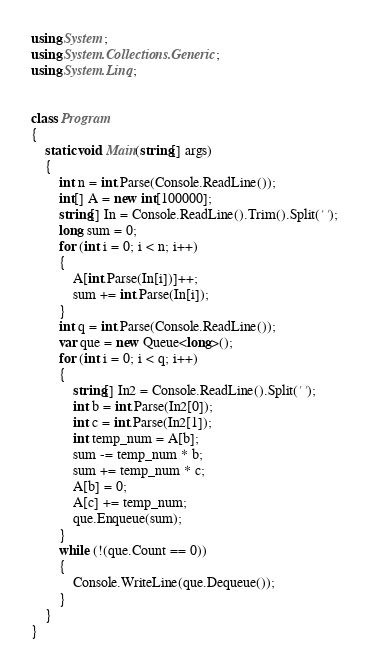<code> <loc_0><loc_0><loc_500><loc_500><_C#_>using System;
using System.Collections.Generic;
using System.Linq;


class Program
{
    static void Main(string[] args)
    {
        int n = int.Parse(Console.ReadLine());
        int[] A = new int[100000];
        string[] In = Console.ReadLine().Trim().Split(' ');
        long sum = 0;
        for (int i = 0; i < n; i++)
        {
            A[int.Parse(In[i])]++;
            sum += int.Parse(In[i]);
        }
        int q = int.Parse(Console.ReadLine());
        var que = new Queue<long>();
        for (int i = 0; i < q; i++)
        {
            string[] In2 = Console.ReadLine().Split(' ');
            int b = int.Parse(In2[0]);
            int c = int.Parse(In2[1]);
            int temp_num = A[b];
            sum -= temp_num * b;
            sum += temp_num * c;
            A[b] = 0;
            A[c] += temp_num;
            que.Enqueue(sum);
        }
        while (!(que.Count == 0))
        {
            Console.WriteLine(que.Dequeue());
        }
    }
}

</code> 